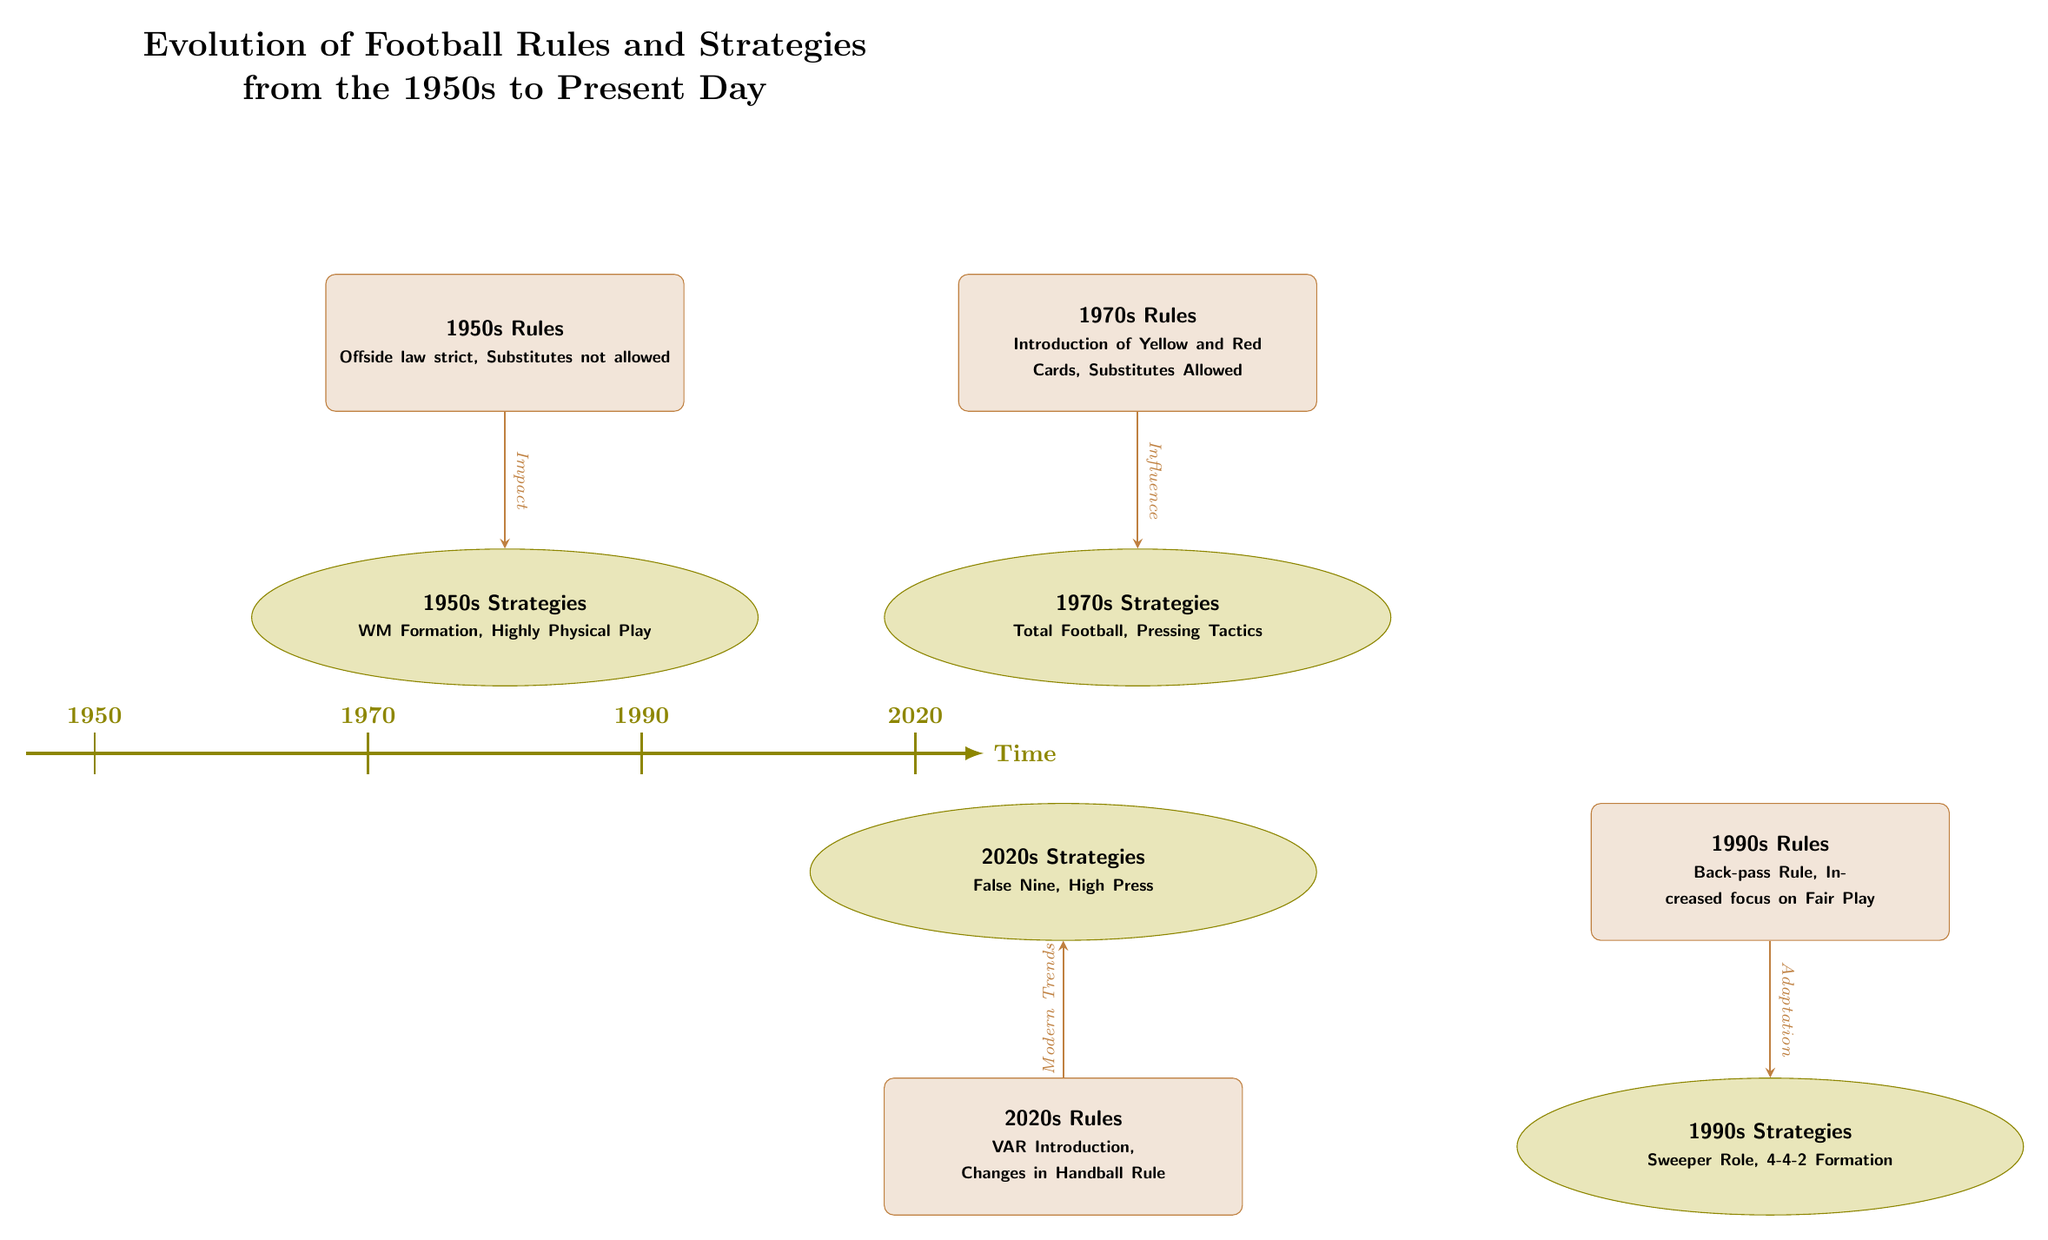What rules were introduced in the 1970s? According to the diagram, the rules introduced in the 1970s include "Introduction of Yellow and Red Cards, Substitutes Allowed." This information can be found in the node designated for the 1970s Rules.
Answer: Introduction of Yellow and Red Cards, Substitutes Allowed What formation was commonly used in the 1990s? The diagram indicates that the 1990s Strategies included the "4-4-2 Formation." This is stated in the node outlining the strategies for that decade.
Answer: 4-4-2 Formation What was the primary focus of the 1990s Rules? The primary focus of the 1990s Rules, as depicted in the node for that era, was on "Increased focus on Fair Play." This indicates a shift in priorities within the game.
Answer: Increased focus on Fair Play How many decades are represented in the diagram? The diagram presents information across four decades: 1950s, 1970s, 1990s, and 2020s. By counting the nodes for each set of rules and strategies, we confirm there are four distinct decades shown.
Answer: 4 Which strategy of the 2020s is related to modern trends? The diagram states that the strategy of the 2020s is "High Press," and that it is influenced by modern trends, as indicated by the arrow connecting the rules node to the strategies node for this decade.
Answer: High Press What significant rule change was made in the 1990s? The significant rule change in the 1990s is "Back-pass Rule," which is specifically mentioned in the rules node for that decade. It signifies a key evolution in the game during that time.
Answer: Back-pass Rule Which formation was associated with the 1970s? The diagram specifies that the major strategy in the 1970s was "Total Football," indicating the tactical approach that characterized that period.
Answer: Total Football What type of influence did the rules of the 1950s have? The rules of the 1950s had an "Impact" on the strategies of that time, as shown by the arrow connecting the rules node to the strategies node for the 1950s.
Answer: Impact 